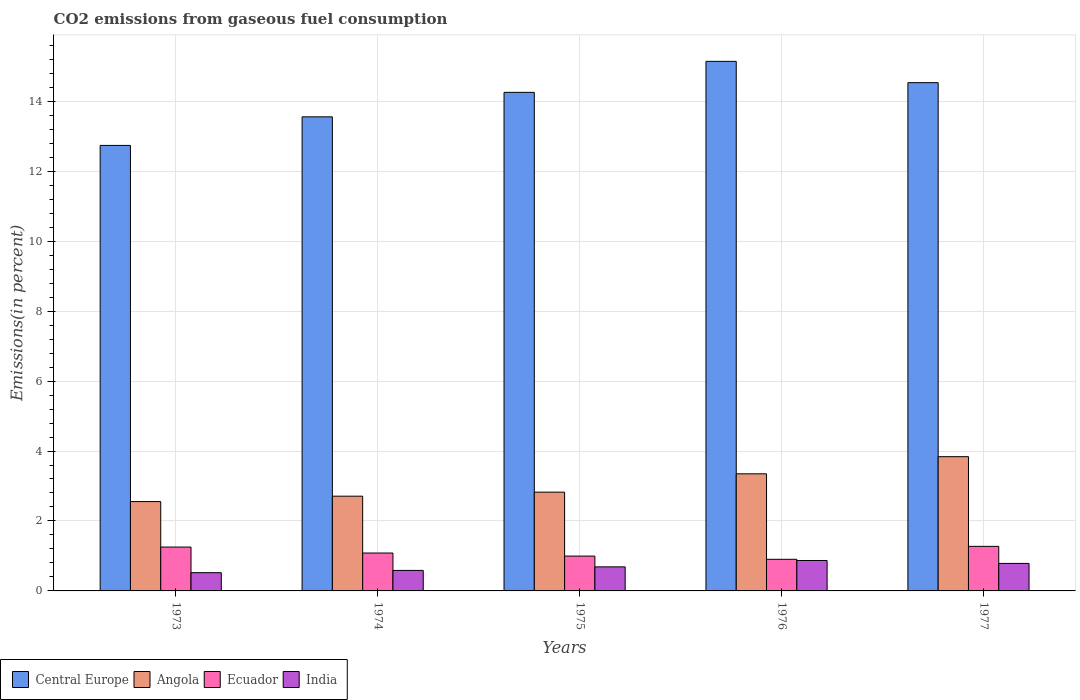How many different coloured bars are there?
Your answer should be very brief. 4. How many groups of bars are there?
Keep it short and to the point. 5. Are the number of bars per tick equal to the number of legend labels?
Provide a succinct answer. Yes. Are the number of bars on each tick of the X-axis equal?
Provide a succinct answer. Yes. How many bars are there on the 5th tick from the right?
Your answer should be very brief. 4. What is the total CO2 emitted in India in 1977?
Provide a short and direct response. 0.79. Across all years, what is the maximum total CO2 emitted in India?
Offer a very short reply. 0.87. Across all years, what is the minimum total CO2 emitted in Angola?
Give a very brief answer. 2.55. In which year was the total CO2 emitted in India minimum?
Your response must be concise. 1973. What is the total total CO2 emitted in Central Europe in the graph?
Keep it short and to the point. 70.22. What is the difference between the total CO2 emitted in Ecuador in 1974 and that in 1975?
Your answer should be compact. 0.09. What is the difference between the total CO2 emitted in Angola in 1975 and the total CO2 emitted in Ecuador in 1976?
Provide a short and direct response. 1.92. What is the average total CO2 emitted in Central Europe per year?
Provide a succinct answer. 14.04. In the year 1974, what is the difference between the total CO2 emitted in Angola and total CO2 emitted in India?
Offer a very short reply. 2.12. In how many years, is the total CO2 emitted in Angola greater than 6.8 %?
Give a very brief answer. 0. What is the ratio of the total CO2 emitted in Central Europe in 1976 to that in 1977?
Keep it short and to the point. 1.04. Is the difference between the total CO2 emitted in Angola in 1974 and 1977 greater than the difference between the total CO2 emitted in India in 1974 and 1977?
Ensure brevity in your answer.  No. What is the difference between the highest and the second highest total CO2 emitted in India?
Your response must be concise. 0.08. What is the difference between the highest and the lowest total CO2 emitted in Angola?
Give a very brief answer. 1.28. In how many years, is the total CO2 emitted in Central Europe greater than the average total CO2 emitted in Central Europe taken over all years?
Offer a terse response. 3. Is the sum of the total CO2 emitted in Angola in 1974 and 1975 greater than the maximum total CO2 emitted in Central Europe across all years?
Your answer should be compact. No. Is it the case that in every year, the sum of the total CO2 emitted in Ecuador and total CO2 emitted in Angola is greater than the sum of total CO2 emitted in Central Europe and total CO2 emitted in India?
Make the answer very short. Yes. What does the 1st bar from the left in 1975 represents?
Your answer should be very brief. Central Europe. Are all the bars in the graph horizontal?
Your answer should be very brief. No. Are the values on the major ticks of Y-axis written in scientific E-notation?
Provide a short and direct response. No. Does the graph contain any zero values?
Offer a very short reply. No. Where does the legend appear in the graph?
Ensure brevity in your answer.  Bottom left. How many legend labels are there?
Keep it short and to the point. 4. What is the title of the graph?
Give a very brief answer. CO2 emissions from gaseous fuel consumption. What is the label or title of the Y-axis?
Make the answer very short. Emissions(in percent). What is the Emissions(in percent) of Central Europe in 1973?
Offer a terse response. 12.74. What is the Emissions(in percent) of Angola in 1973?
Your response must be concise. 2.55. What is the Emissions(in percent) of Ecuador in 1973?
Offer a very short reply. 1.25. What is the Emissions(in percent) in India in 1973?
Provide a succinct answer. 0.52. What is the Emissions(in percent) in Central Europe in 1974?
Your answer should be very brief. 13.55. What is the Emissions(in percent) in Angola in 1974?
Keep it short and to the point. 2.71. What is the Emissions(in percent) of Ecuador in 1974?
Keep it short and to the point. 1.08. What is the Emissions(in percent) in India in 1974?
Offer a very short reply. 0.59. What is the Emissions(in percent) of Central Europe in 1975?
Ensure brevity in your answer.  14.25. What is the Emissions(in percent) in Angola in 1975?
Keep it short and to the point. 2.82. What is the Emissions(in percent) in Ecuador in 1975?
Your response must be concise. 1. What is the Emissions(in percent) in India in 1975?
Offer a terse response. 0.69. What is the Emissions(in percent) in Central Europe in 1976?
Your response must be concise. 15.14. What is the Emissions(in percent) in Angola in 1976?
Offer a terse response. 3.35. What is the Emissions(in percent) of Ecuador in 1976?
Offer a terse response. 0.9. What is the Emissions(in percent) in India in 1976?
Offer a terse response. 0.87. What is the Emissions(in percent) in Central Europe in 1977?
Make the answer very short. 14.53. What is the Emissions(in percent) in Angola in 1977?
Offer a very short reply. 3.84. What is the Emissions(in percent) of Ecuador in 1977?
Offer a terse response. 1.27. What is the Emissions(in percent) of India in 1977?
Give a very brief answer. 0.79. Across all years, what is the maximum Emissions(in percent) of Central Europe?
Your response must be concise. 15.14. Across all years, what is the maximum Emissions(in percent) in Angola?
Provide a succinct answer. 3.84. Across all years, what is the maximum Emissions(in percent) of Ecuador?
Make the answer very short. 1.27. Across all years, what is the maximum Emissions(in percent) of India?
Provide a short and direct response. 0.87. Across all years, what is the minimum Emissions(in percent) of Central Europe?
Ensure brevity in your answer.  12.74. Across all years, what is the minimum Emissions(in percent) in Angola?
Your answer should be very brief. 2.55. Across all years, what is the minimum Emissions(in percent) in Ecuador?
Make the answer very short. 0.9. Across all years, what is the minimum Emissions(in percent) of India?
Your answer should be compact. 0.52. What is the total Emissions(in percent) in Central Europe in the graph?
Provide a succinct answer. 70.22. What is the total Emissions(in percent) of Angola in the graph?
Keep it short and to the point. 15.27. What is the total Emissions(in percent) of Ecuador in the graph?
Make the answer very short. 5.51. What is the total Emissions(in percent) in India in the graph?
Ensure brevity in your answer.  3.45. What is the difference between the Emissions(in percent) of Central Europe in 1973 and that in 1974?
Offer a terse response. -0.82. What is the difference between the Emissions(in percent) in Angola in 1973 and that in 1974?
Make the answer very short. -0.15. What is the difference between the Emissions(in percent) of Ecuador in 1973 and that in 1974?
Your answer should be very brief. 0.17. What is the difference between the Emissions(in percent) in India in 1973 and that in 1974?
Keep it short and to the point. -0.07. What is the difference between the Emissions(in percent) in Central Europe in 1973 and that in 1975?
Your answer should be very brief. -1.52. What is the difference between the Emissions(in percent) of Angola in 1973 and that in 1975?
Give a very brief answer. -0.27. What is the difference between the Emissions(in percent) of Ecuador in 1973 and that in 1975?
Offer a terse response. 0.26. What is the difference between the Emissions(in percent) of India in 1973 and that in 1975?
Provide a short and direct response. -0.17. What is the difference between the Emissions(in percent) in Central Europe in 1973 and that in 1976?
Offer a very short reply. -2.4. What is the difference between the Emissions(in percent) in Angola in 1973 and that in 1976?
Your answer should be compact. -0.79. What is the difference between the Emissions(in percent) in Ecuador in 1973 and that in 1976?
Keep it short and to the point. 0.35. What is the difference between the Emissions(in percent) in India in 1973 and that in 1976?
Offer a very short reply. -0.35. What is the difference between the Emissions(in percent) in Central Europe in 1973 and that in 1977?
Your response must be concise. -1.79. What is the difference between the Emissions(in percent) of Angola in 1973 and that in 1977?
Your response must be concise. -1.28. What is the difference between the Emissions(in percent) in Ecuador in 1973 and that in 1977?
Your answer should be very brief. -0.02. What is the difference between the Emissions(in percent) in India in 1973 and that in 1977?
Provide a succinct answer. -0.27. What is the difference between the Emissions(in percent) of Central Europe in 1974 and that in 1975?
Give a very brief answer. -0.7. What is the difference between the Emissions(in percent) in Angola in 1974 and that in 1975?
Keep it short and to the point. -0.12. What is the difference between the Emissions(in percent) in Ecuador in 1974 and that in 1975?
Your answer should be very brief. 0.09. What is the difference between the Emissions(in percent) of India in 1974 and that in 1975?
Provide a short and direct response. -0.1. What is the difference between the Emissions(in percent) of Central Europe in 1974 and that in 1976?
Provide a succinct answer. -1.59. What is the difference between the Emissions(in percent) of Angola in 1974 and that in 1976?
Make the answer very short. -0.64. What is the difference between the Emissions(in percent) in Ecuador in 1974 and that in 1976?
Your answer should be very brief. 0.18. What is the difference between the Emissions(in percent) of India in 1974 and that in 1976?
Your answer should be very brief. -0.28. What is the difference between the Emissions(in percent) of Central Europe in 1974 and that in 1977?
Give a very brief answer. -0.98. What is the difference between the Emissions(in percent) of Angola in 1974 and that in 1977?
Your answer should be compact. -1.13. What is the difference between the Emissions(in percent) in Ecuador in 1974 and that in 1977?
Provide a succinct answer. -0.19. What is the difference between the Emissions(in percent) of Central Europe in 1975 and that in 1976?
Your answer should be compact. -0.89. What is the difference between the Emissions(in percent) in Angola in 1975 and that in 1976?
Keep it short and to the point. -0.52. What is the difference between the Emissions(in percent) in Ecuador in 1975 and that in 1976?
Give a very brief answer. 0.09. What is the difference between the Emissions(in percent) of India in 1975 and that in 1976?
Ensure brevity in your answer.  -0.18. What is the difference between the Emissions(in percent) in Central Europe in 1975 and that in 1977?
Offer a very short reply. -0.28. What is the difference between the Emissions(in percent) in Angola in 1975 and that in 1977?
Give a very brief answer. -1.01. What is the difference between the Emissions(in percent) of Ecuador in 1975 and that in 1977?
Provide a short and direct response. -0.28. What is the difference between the Emissions(in percent) of India in 1975 and that in 1977?
Make the answer very short. -0.1. What is the difference between the Emissions(in percent) in Central Europe in 1976 and that in 1977?
Your answer should be compact. 0.61. What is the difference between the Emissions(in percent) of Angola in 1976 and that in 1977?
Your response must be concise. -0.49. What is the difference between the Emissions(in percent) in Ecuador in 1976 and that in 1977?
Your answer should be compact. -0.37. What is the difference between the Emissions(in percent) of India in 1976 and that in 1977?
Provide a short and direct response. 0.08. What is the difference between the Emissions(in percent) in Central Europe in 1973 and the Emissions(in percent) in Angola in 1974?
Your answer should be compact. 10.03. What is the difference between the Emissions(in percent) in Central Europe in 1973 and the Emissions(in percent) in Ecuador in 1974?
Provide a short and direct response. 11.65. What is the difference between the Emissions(in percent) in Central Europe in 1973 and the Emissions(in percent) in India in 1974?
Keep it short and to the point. 12.15. What is the difference between the Emissions(in percent) in Angola in 1973 and the Emissions(in percent) in Ecuador in 1974?
Your answer should be compact. 1.47. What is the difference between the Emissions(in percent) of Angola in 1973 and the Emissions(in percent) of India in 1974?
Ensure brevity in your answer.  1.97. What is the difference between the Emissions(in percent) of Ecuador in 1973 and the Emissions(in percent) of India in 1974?
Offer a terse response. 0.67. What is the difference between the Emissions(in percent) in Central Europe in 1973 and the Emissions(in percent) in Angola in 1975?
Your answer should be compact. 9.91. What is the difference between the Emissions(in percent) of Central Europe in 1973 and the Emissions(in percent) of Ecuador in 1975?
Your answer should be very brief. 11.74. What is the difference between the Emissions(in percent) of Central Europe in 1973 and the Emissions(in percent) of India in 1975?
Provide a succinct answer. 12.05. What is the difference between the Emissions(in percent) in Angola in 1973 and the Emissions(in percent) in Ecuador in 1975?
Your response must be concise. 1.56. What is the difference between the Emissions(in percent) in Angola in 1973 and the Emissions(in percent) in India in 1975?
Make the answer very short. 1.87. What is the difference between the Emissions(in percent) of Ecuador in 1973 and the Emissions(in percent) of India in 1975?
Give a very brief answer. 0.57. What is the difference between the Emissions(in percent) of Central Europe in 1973 and the Emissions(in percent) of Angola in 1976?
Keep it short and to the point. 9.39. What is the difference between the Emissions(in percent) in Central Europe in 1973 and the Emissions(in percent) in Ecuador in 1976?
Offer a very short reply. 11.83. What is the difference between the Emissions(in percent) of Central Europe in 1973 and the Emissions(in percent) of India in 1976?
Provide a succinct answer. 11.87. What is the difference between the Emissions(in percent) of Angola in 1973 and the Emissions(in percent) of Ecuador in 1976?
Your answer should be compact. 1.65. What is the difference between the Emissions(in percent) of Angola in 1973 and the Emissions(in percent) of India in 1976?
Provide a succinct answer. 1.68. What is the difference between the Emissions(in percent) in Ecuador in 1973 and the Emissions(in percent) in India in 1976?
Your answer should be very brief. 0.38. What is the difference between the Emissions(in percent) of Central Europe in 1973 and the Emissions(in percent) of Angola in 1977?
Provide a succinct answer. 8.9. What is the difference between the Emissions(in percent) in Central Europe in 1973 and the Emissions(in percent) in Ecuador in 1977?
Offer a very short reply. 11.46. What is the difference between the Emissions(in percent) of Central Europe in 1973 and the Emissions(in percent) of India in 1977?
Your response must be concise. 11.95. What is the difference between the Emissions(in percent) in Angola in 1973 and the Emissions(in percent) in Ecuador in 1977?
Your answer should be very brief. 1.28. What is the difference between the Emissions(in percent) of Angola in 1973 and the Emissions(in percent) of India in 1977?
Offer a very short reply. 1.77. What is the difference between the Emissions(in percent) in Ecuador in 1973 and the Emissions(in percent) in India in 1977?
Offer a very short reply. 0.47. What is the difference between the Emissions(in percent) of Central Europe in 1974 and the Emissions(in percent) of Angola in 1975?
Give a very brief answer. 10.73. What is the difference between the Emissions(in percent) of Central Europe in 1974 and the Emissions(in percent) of Ecuador in 1975?
Provide a short and direct response. 12.56. What is the difference between the Emissions(in percent) in Central Europe in 1974 and the Emissions(in percent) in India in 1975?
Make the answer very short. 12.87. What is the difference between the Emissions(in percent) of Angola in 1974 and the Emissions(in percent) of Ecuador in 1975?
Give a very brief answer. 1.71. What is the difference between the Emissions(in percent) of Angola in 1974 and the Emissions(in percent) of India in 1975?
Your answer should be very brief. 2.02. What is the difference between the Emissions(in percent) of Ecuador in 1974 and the Emissions(in percent) of India in 1975?
Offer a terse response. 0.4. What is the difference between the Emissions(in percent) of Central Europe in 1974 and the Emissions(in percent) of Angola in 1976?
Provide a short and direct response. 10.21. What is the difference between the Emissions(in percent) of Central Europe in 1974 and the Emissions(in percent) of Ecuador in 1976?
Your response must be concise. 12.65. What is the difference between the Emissions(in percent) in Central Europe in 1974 and the Emissions(in percent) in India in 1976?
Provide a succinct answer. 12.68. What is the difference between the Emissions(in percent) of Angola in 1974 and the Emissions(in percent) of Ecuador in 1976?
Offer a terse response. 1.8. What is the difference between the Emissions(in percent) of Angola in 1974 and the Emissions(in percent) of India in 1976?
Your answer should be compact. 1.84. What is the difference between the Emissions(in percent) in Ecuador in 1974 and the Emissions(in percent) in India in 1976?
Your answer should be compact. 0.21. What is the difference between the Emissions(in percent) of Central Europe in 1974 and the Emissions(in percent) of Angola in 1977?
Make the answer very short. 9.72. What is the difference between the Emissions(in percent) of Central Europe in 1974 and the Emissions(in percent) of Ecuador in 1977?
Make the answer very short. 12.28. What is the difference between the Emissions(in percent) in Central Europe in 1974 and the Emissions(in percent) in India in 1977?
Offer a terse response. 12.77. What is the difference between the Emissions(in percent) in Angola in 1974 and the Emissions(in percent) in Ecuador in 1977?
Make the answer very short. 1.43. What is the difference between the Emissions(in percent) of Angola in 1974 and the Emissions(in percent) of India in 1977?
Provide a succinct answer. 1.92. What is the difference between the Emissions(in percent) in Ecuador in 1974 and the Emissions(in percent) in India in 1977?
Give a very brief answer. 0.3. What is the difference between the Emissions(in percent) in Central Europe in 1975 and the Emissions(in percent) in Angola in 1976?
Provide a succinct answer. 10.91. What is the difference between the Emissions(in percent) in Central Europe in 1975 and the Emissions(in percent) in Ecuador in 1976?
Keep it short and to the point. 13.35. What is the difference between the Emissions(in percent) in Central Europe in 1975 and the Emissions(in percent) in India in 1976?
Ensure brevity in your answer.  13.38. What is the difference between the Emissions(in percent) of Angola in 1975 and the Emissions(in percent) of Ecuador in 1976?
Offer a terse response. 1.92. What is the difference between the Emissions(in percent) of Angola in 1975 and the Emissions(in percent) of India in 1976?
Your answer should be compact. 1.95. What is the difference between the Emissions(in percent) in Ecuador in 1975 and the Emissions(in percent) in India in 1976?
Provide a succinct answer. 0.13. What is the difference between the Emissions(in percent) of Central Europe in 1975 and the Emissions(in percent) of Angola in 1977?
Keep it short and to the point. 10.42. What is the difference between the Emissions(in percent) in Central Europe in 1975 and the Emissions(in percent) in Ecuador in 1977?
Give a very brief answer. 12.98. What is the difference between the Emissions(in percent) in Central Europe in 1975 and the Emissions(in percent) in India in 1977?
Give a very brief answer. 13.47. What is the difference between the Emissions(in percent) in Angola in 1975 and the Emissions(in percent) in Ecuador in 1977?
Give a very brief answer. 1.55. What is the difference between the Emissions(in percent) in Angola in 1975 and the Emissions(in percent) in India in 1977?
Your answer should be very brief. 2.04. What is the difference between the Emissions(in percent) of Ecuador in 1975 and the Emissions(in percent) of India in 1977?
Provide a short and direct response. 0.21. What is the difference between the Emissions(in percent) of Central Europe in 1976 and the Emissions(in percent) of Angola in 1977?
Provide a succinct answer. 11.3. What is the difference between the Emissions(in percent) in Central Europe in 1976 and the Emissions(in percent) in Ecuador in 1977?
Offer a terse response. 13.87. What is the difference between the Emissions(in percent) in Central Europe in 1976 and the Emissions(in percent) in India in 1977?
Offer a terse response. 14.35. What is the difference between the Emissions(in percent) in Angola in 1976 and the Emissions(in percent) in Ecuador in 1977?
Keep it short and to the point. 2.07. What is the difference between the Emissions(in percent) in Angola in 1976 and the Emissions(in percent) in India in 1977?
Your answer should be compact. 2.56. What is the difference between the Emissions(in percent) in Ecuador in 1976 and the Emissions(in percent) in India in 1977?
Provide a succinct answer. 0.12. What is the average Emissions(in percent) in Central Europe per year?
Keep it short and to the point. 14.04. What is the average Emissions(in percent) in Angola per year?
Give a very brief answer. 3.05. What is the average Emissions(in percent) in Ecuador per year?
Provide a short and direct response. 1.1. What is the average Emissions(in percent) in India per year?
Give a very brief answer. 0.69. In the year 1973, what is the difference between the Emissions(in percent) in Central Europe and Emissions(in percent) in Angola?
Offer a terse response. 10.18. In the year 1973, what is the difference between the Emissions(in percent) in Central Europe and Emissions(in percent) in Ecuador?
Offer a terse response. 11.48. In the year 1973, what is the difference between the Emissions(in percent) of Central Europe and Emissions(in percent) of India?
Ensure brevity in your answer.  12.22. In the year 1973, what is the difference between the Emissions(in percent) of Angola and Emissions(in percent) of Ecuador?
Provide a short and direct response. 1.3. In the year 1973, what is the difference between the Emissions(in percent) of Angola and Emissions(in percent) of India?
Offer a very short reply. 2.03. In the year 1973, what is the difference between the Emissions(in percent) in Ecuador and Emissions(in percent) in India?
Your answer should be very brief. 0.73. In the year 1974, what is the difference between the Emissions(in percent) in Central Europe and Emissions(in percent) in Angola?
Make the answer very short. 10.85. In the year 1974, what is the difference between the Emissions(in percent) of Central Europe and Emissions(in percent) of Ecuador?
Your answer should be compact. 12.47. In the year 1974, what is the difference between the Emissions(in percent) in Central Europe and Emissions(in percent) in India?
Ensure brevity in your answer.  12.97. In the year 1974, what is the difference between the Emissions(in percent) in Angola and Emissions(in percent) in Ecuador?
Your answer should be compact. 1.63. In the year 1974, what is the difference between the Emissions(in percent) of Angola and Emissions(in percent) of India?
Provide a short and direct response. 2.12. In the year 1974, what is the difference between the Emissions(in percent) in Ecuador and Emissions(in percent) in India?
Keep it short and to the point. 0.5. In the year 1975, what is the difference between the Emissions(in percent) in Central Europe and Emissions(in percent) in Angola?
Offer a terse response. 11.43. In the year 1975, what is the difference between the Emissions(in percent) in Central Europe and Emissions(in percent) in Ecuador?
Make the answer very short. 13.26. In the year 1975, what is the difference between the Emissions(in percent) in Central Europe and Emissions(in percent) in India?
Offer a terse response. 13.57. In the year 1975, what is the difference between the Emissions(in percent) in Angola and Emissions(in percent) in Ecuador?
Keep it short and to the point. 1.83. In the year 1975, what is the difference between the Emissions(in percent) of Angola and Emissions(in percent) of India?
Make the answer very short. 2.14. In the year 1975, what is the difference between the Emissions(in percent) in Ecuador and Emissions(in percent) in India?
Offer a terse response. 0.31. In the year 1976, what is the difference between the Emissions(in percent) in Central Europe and Emissions(in percent) in Angola?
Your answer should be very brief. 11.79. In the year 1976, what is the difference between the Emissions(in percent) of Central Europe and Emissions(in percent) of Ecuador?
Give a very brief answer. 14.24. In the year 1976, what is the difference between the Emissions(in percent) in Central Europe and Emissions(in percent) in India?
Provide a succinct answer. 14.27. In the year 1976, what is the difference between the Emissions(in percent) in Angola and Emissions(in percent) in Ecuador?
Your answer should be compact. 2.44. In the year 1976, what is the difference between the Emissions(in percent) in Angola and Emissions(in percent) in India?
Provide a succinct answer. 2.48. In the year 1976, what is the difference between the Emissions(in percent) in Ecuador and Emissions(in percent) in India?
Give a very brief answer. 0.03. In the year 1977, what is the difference between the Emissions(in percent) in Central Europe and Emissions(in percent) in Angola?
Your response must be concise. 10.69. In the year 1977, what is the difference between the Emissions(in percent) in Central Europe and Emissions(in percent) in Ecuador?
Provide a short and direct response. 13.26. In the year 1977, what is the difference between the Emissions(in percent) in Central Europe and Emissions(in percent) in India?
Give a very brief answer. 13.75. In the year 1977, what is the difference between the Emissions(in percent) of Angola and Emissions(in percent) of Ecuador?
Provide a succinct answer. 2.56. In the year 1977, what is the difference between the Emissions(in percent) in Angola and Emissions(in percent) in India?
Ensure brevity in your answer.  3.05. In the year 1977, what is the difference between the Emissions(in percent) in Ecuador and Emissions(in percent) in India?
Provide a short and direct response. 0.49. What is the ratio of the Emissions(in percent) of Central Europe in 1973 to that in 1974?
Give a very brief answer. 0.94. What is the ratio of the Emissions(in percent) in Angola in 1973 to that in 1974?
Your answer should be compact. 0.94. What is the ratio of the Emissions(in percent) in Ecuador in 1973 to that in 1974?
Offer a very short reply. 1.16. What is the ratio of the Emissions(in percent) in India in 1973 to that in 1974?
Make the answer very short. 0.89. What is the ratio of the Emissions(in percent) in Central Europe in 1973 to that in 1975?
Your answer should be compact. 0.89. What is the ratio of the Emissions(in percent) in Angola in 1973 to that in 1975?
Keep it short and to the point. 0.9. What is the ratio of the Emissions(in percent) in Ecuador in 1973 to that in 1975?
Ensure brevity in your answer.  1.26. What is the ratio of the Emissions(in percent) of India in 1973 to that in 1975?
Provide a succinct answer. 0.76. What is the ratio of the Emissions(in percent) in Central Europe in 1973 to that in 1976?
Ensure brevity in your answer.  0.84. What is the ratio of the Emissions(in percent) of Angola in 1973 to that in 1976?
Offer a very short reply. 0.76. What is the ratio of the Emissions(in percent) of Ecuador in 1973 to that in 1976?
Give a very brief answer. 1.39. What is the ratio of the Emissions(in percent) of India in 1973 to that in 1976?
Ensure brevity in your answer.  0.6. What is the ratio of the Emissions(in percent) of Central Europe in 1973 to that in 1977?
Keep it short and to the point. 0.88. What is the ratio of the Emissions(in percent) of Angola in 1973 to that in 1977?
Your answer should be compact. 0.67. What is the ratio of the Emissions(in percent) in Ecuador in 1973 to that in 1977?
Keep it short and to the point. 0.98. What is the ratio of the Emissions(in percent) of India in 1973 to that in 1977?
Offer a terse response. 0.66. What is the ratio of the Emissions(in percent) in Central Europe in 1974 to that in 1975?
Offer a very short reply. 0.95. What is the ratio of the Emissions(in percent) in Angola in 1974 to that in 1975?
Ensure brevity in your answer.  0.96. What is the ratio of the Emissions(in percent) in Ecuador in 1974 to that in 1975?
Your answer should be very brief. 1.09. What is the ratio of the Emissions(in percent) in India in 1974 to that in 1975?
Ensure brevity in your answer.  0.85. What is the ratio of the Emissions(in percent) of Central Europe in 1974 to that in 1976?
Provide a succinct answer. 0.9. What is the ratio of the Emissions(in percent) of Angola in 1974 to that in 1976?
Offer a terse response. 0.81. What is the ratio of the Emissions(in percent) of Ecuador in 1974 to that in 1976?
Provide a short and direct response. 1.2. What is the ratio of the Emissions(in percent) of India in 1974 to that in 1976?
Provide a short and direct response. 0.67. What is the ratio of the Emissions(in percent) in Central Europe in 1974 to that in 1977?
Offer a very short reply. 0.93. What is the ratio of the Emissions(in percent) in Angola in 1974 to that in 1977?
Your response must be concise. 0.71. What is the ratio of the Emissions(in percent) of Ecuador in 1974 to that in 1977?
Provide a short and direct response. 0.85. What is the ratio of the Emissions(in percent) in India in 1974 to that in 1977?
Your answer should be compact. 0.75. What is the ratio of the Emissions(in percent) of Central Europe in 1975 to that in 1976?
Offer a terse response. 0.94. What is the ratio of the Emissions(in percent) of Angola in 1975 to that in 1976?
Ensure brevity in your answer.  0.84. What is the ratio of the Emissions(in percent) in Ecuador in 1975 to that in 1976?
Your answer should be compact. 1.1. What is the ratio of the Emissions(in percent) in India in 1975 to that in 1976?
Keep it short and to the point. 0.79. What is the ratio of the Emissions(in percent) in Central Europe in 1975 to that in 1977?
Keep it short and to the point. 0.98. What is the ratio of the Emissions(in percent) in Angola in 1975 to that in 1977?
Provide a succinct answer. 0.74. What is the ratio of the Emissions(in percent) of Ecuador in 1975 to that in 1977?
Make the answer very short. 0.78. What is the ratio of the Emissions(in percent) of India in 1975 to that in 1977?
Keep it short and to the point. 0.87. What is the ratio of the Emissions(in percent) of Central Europe in 1976 to that in 1977?
Your answer should be compact. 1.04. What is the ratio of the Emissions(in percent) in Angola in 1976 to that in 1977?
Keep it short and to the point. 0.87. What is the ratio of the Emissions(in percent) in Ecuador in 1976 to that in 1977?
Provide a short and direct response. 0.71. What is the ratio of the Emissions(in percent) in India in 1976 to that in 1977?
Provide a succinct answer. 1.11. What is the difference between the highest and the second highest Emissions(in percent) in Central Europe?
Offer a very short reply. 0.61. What is the difference between the highest and the second highest Emissions(in percent) in Angola?
Give a very brief answer. 0.49. What is the difference between the highest and the second highest Emissions(in percent) in Ecuador?
Your answer should be very brief. 0.02. What is the difference between the highest and the second highest Emissions(in percent) in India?
Offer a very short reply. 0.08. What is the difference between the highest and the lowest Emissions(in percent) of Central Europe?
Ensure brevity in your answer.  2.4. What is the difference between the highest and the lowest Emissions(in percent) in Angola?
Give a very brief answer. 1.28. What is the difference between the highest and the lowest Emissions(in percent) of Ecuador?
Offer a very short reply. 0.37. What is the difference between the highest and the lowest Emissions(in percent) of India?
Provide a succinct answer. 0.35. 